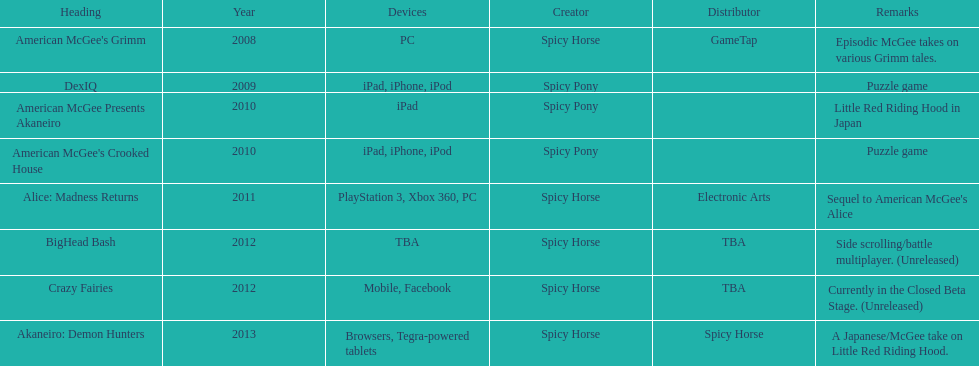According to the table, what is the last title that spicy horse produced? Akaneiro: Demon Hunters. Can you give me this table as a dict? {'header': ['Heading', 'Year', 'Devices', 'Creator', 'Distributor', 'Remarks'], 'rows': [["American McGee's Grimm", '2008', 'PC', 'Spicy Horse', 'GameTap', 'Episodic McGee takes on various Grimm tales.'], ['DexIQ', '2009', 'iPad, iPhone, iPod', 'Spicy Pony', '', 'Puzzle game'], ['American McGee Presents Akaneiro', '2010', 'iPad', 'Spicy Pony', '', 'Little Red Riding Hood in Japan'], ["American McGee's Crooked House", '2010', 'iPad, iPhone, iPod', 'Spicy Pony', '', 'Puzzle game'], ['Alice: Madness Returns', '2011', 'PlayStation 3, Xbox 360, PC', 'Spicy Horse', 'Electronic Arts', "Sequel to American McGee's Alice"], ['BigHead Bash', '2012', 'TBA', 'Spicy Horse', 'TBA', 'Side scrolling/battle multiplayer. (Unreleased)'], ['Crazy Fairies', '2012', 'Mobile, Facebook', 'Spicy Horse', 'TBA', 'Currently in the Closed Beta Stage. (Unreleased)'], ['Akaneiro: Demon Hunters', '2013', 'Browsers, Tegra-powered tablets', 'Spicy Horse', 'Spicy Horse', 'A Japanese/McGee take on Little Red Riding Hood.']]} 